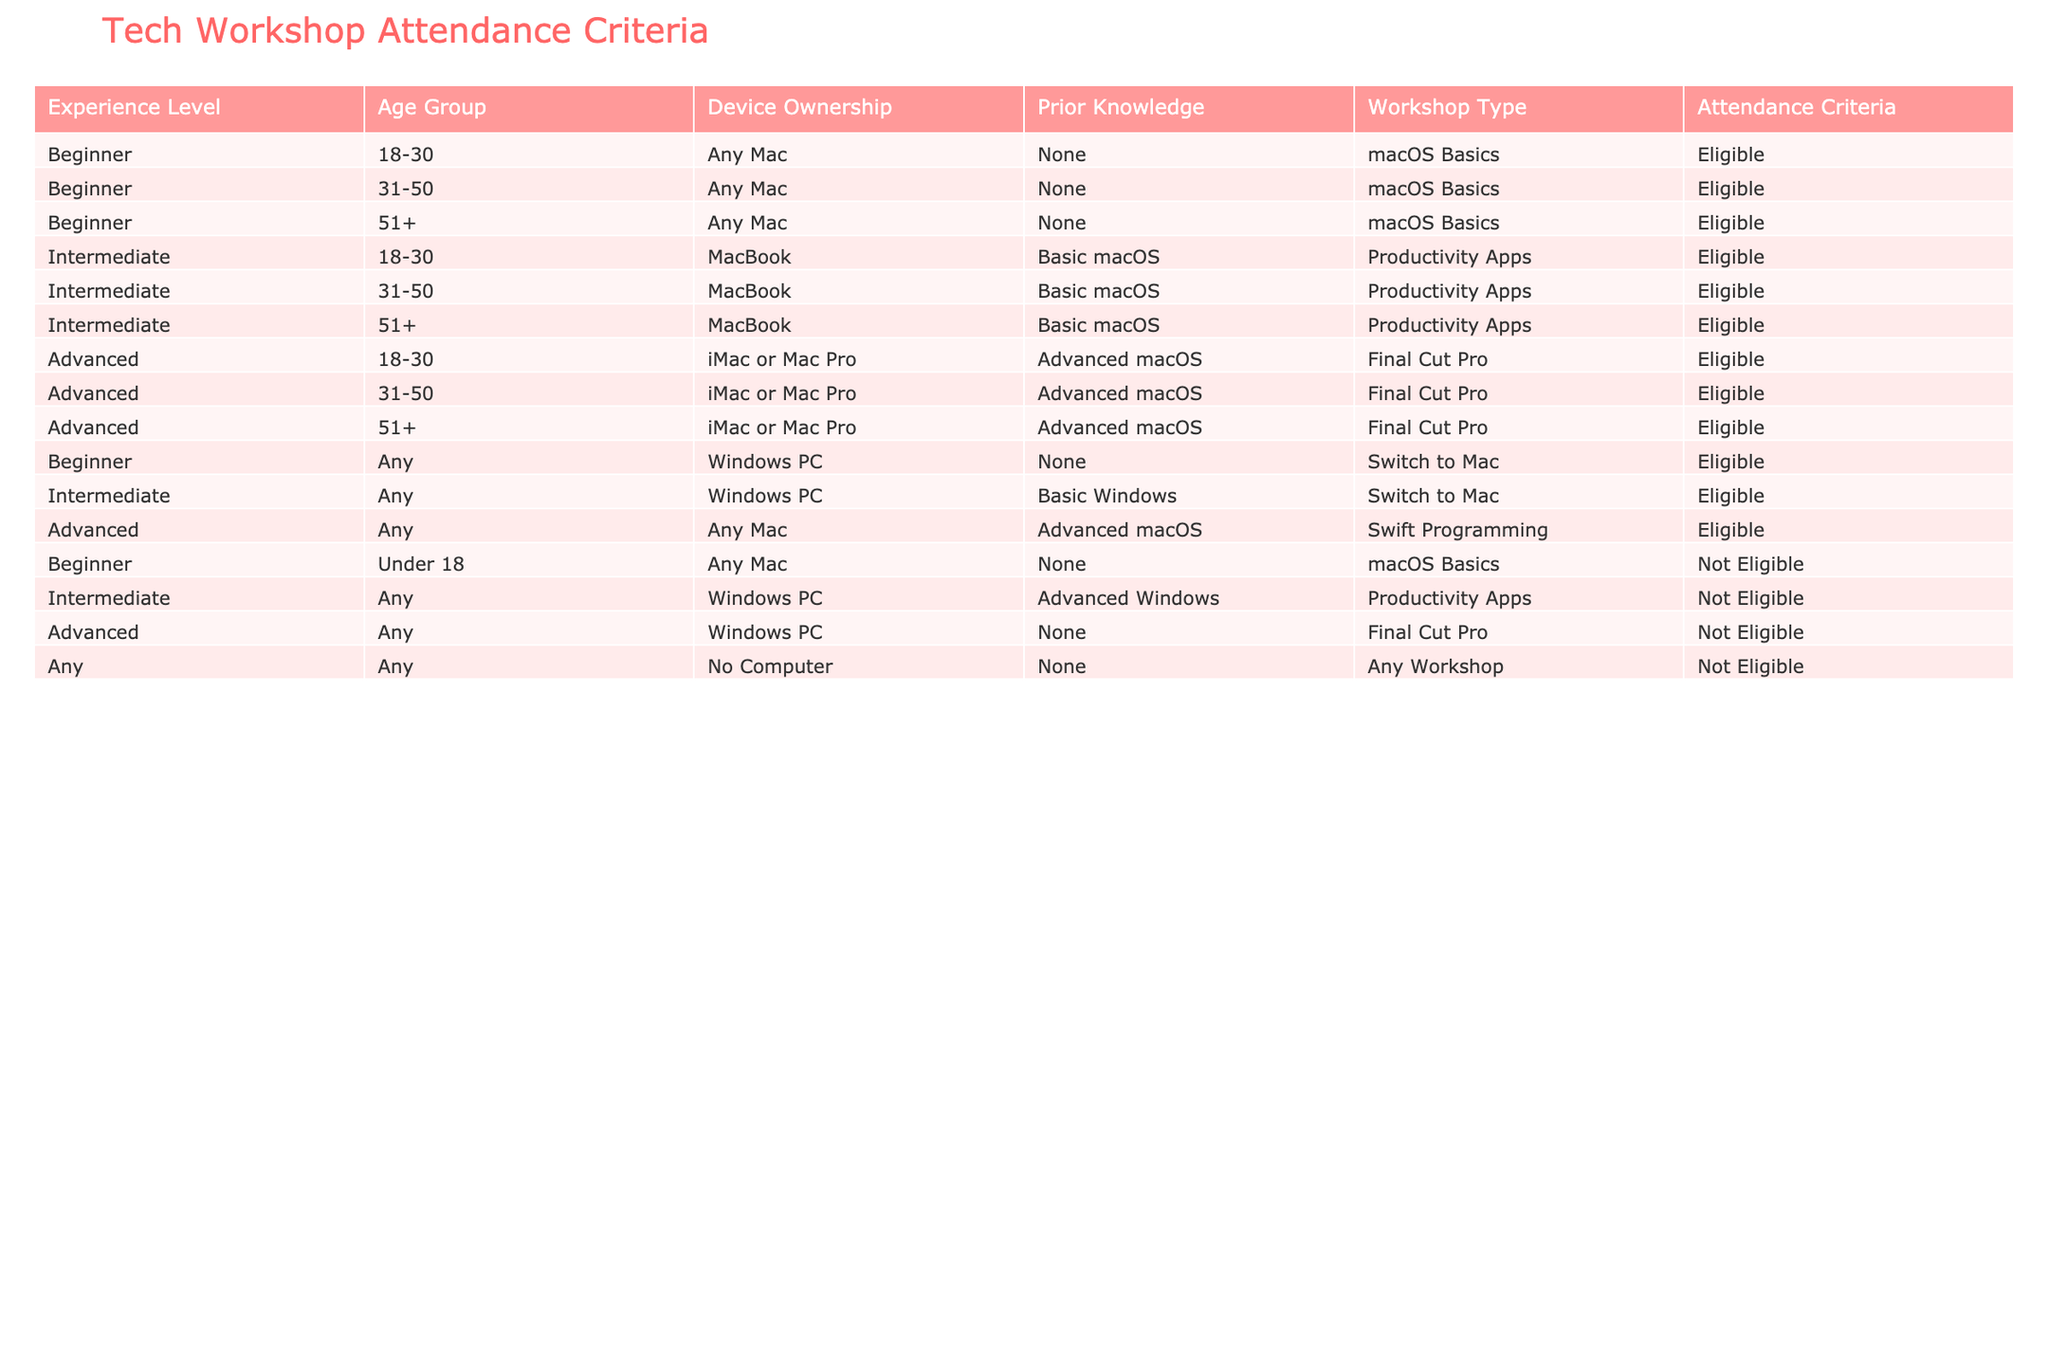What is the attendance criteria for a Beginner in the 18-30 age group? In the table, when searching for the "Beginner" experience level and the "18-30" age group, we find that the "Attendance Criteria" is listed as "Eligible".
Answer: Eligible Is an Advanced user with no computer eligible to attend any workshop? According to the table, under the "Advanced" experience level and "No Computer" device ownership, the "Attendance Criteria" is marked as "Not Eligible". Therefore, the statement is true.
Answer: No How many workshop types are available for Intermediate attendees? The table lists two workshop types for the "Intermediate" experience level: "Productivity Apps" and "Switch to Mac". Therefore, there are two distinct workshop types available.
Answer: 2 Can a person aged 40, who owns a MacBook but has only basic Windows knowledge, attend the Productivity Apps workshop? By examining the table, an individual aged 40 falls under the age group of 31-50. For the "Intermediate" level, owning a MacBook and having basic macOS knowledge makes them eligible for the "Productivity Apps" workshop. Since they have basic Windows knowledge, which doesn't align, they are not eligible.
Answer: No Are all age groups eligible for the macOS Basics workshop for Beginners? The table shows that all age groups (18-30, 31-50, and 51+) with the "Beginner" experience level and owning any Mac are eligible for the "macOS Basics" workshop.
Answer: Yes What is the total number of attendees eligible for the Swift Programming workshop? Looking at the table, the "Swift Programming" workshop is available for those with an "Advanced" experience level who own any Mac. Since there are no age restrictions or other conditions, all users fitting this profile are eligible, leading to a total of three distinct entries in the table.
Answer: 3 Is there any criteria listed for attendees under the age of 18? The table specifies that Beginners under the age of 18 are classified as "Not Eligible" for the "macOS Basics" workshop, clearly indicating that there is criteria related to this age group.
Answer: Yes Which workshop type has the least eligibility across participants? By analyzing attendance criteria for each workshop type, "Final Cut Pro" has one entry indicating "Not Eligible" for those with Windows PCs while "Swift Programming" has no such conditions. Therefore, "Final Cut Pro" has the least eligibility across participants.
Answer: Final Cut Pro What is the eligibility status for an Advanced participant in the age group of 51+ with Windows PC? Checking the table, for an "Advanced" participant who owns a Windows PC, the criteria are listed as "Not Eligible". Hence, they cannot participate.
Answer: Not Eligible 